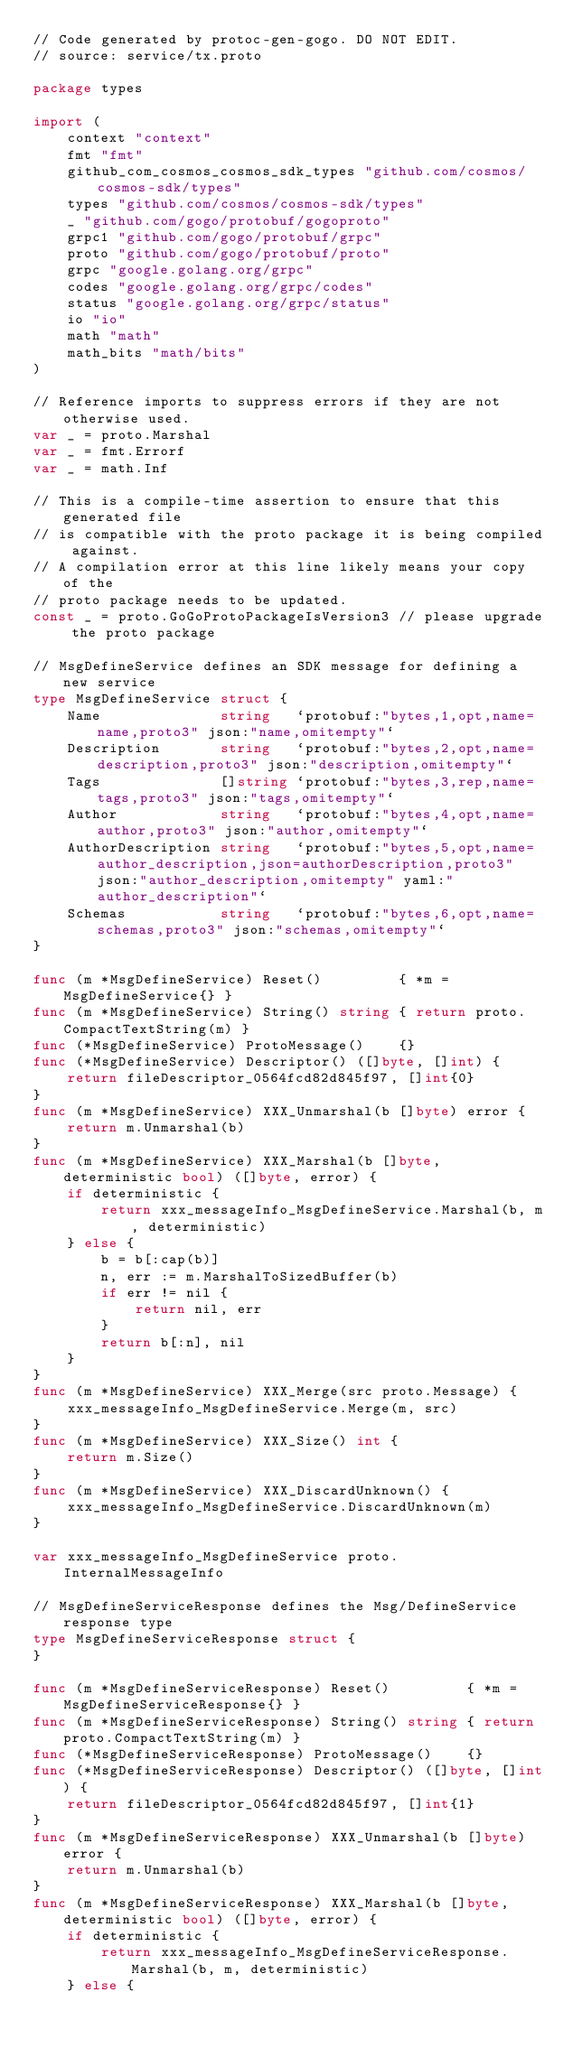<code> <loc_0><loc_0><loc_500><loc_500><_Go_>// Code generated by protoc-gen-gogo. DO NOT EDIT.
// source: service/tx.proto

package types

import (
	context "context"
	fmt "fmt"
	github_com_cosmos_cosmos_sdk_types "github.com/cosmos/cosmos-sdk/types"
	types "github.com/cosmos/cosmos-sdk/types"
	_ "github.com/gogo/protobuf/gogoproto"
	grpc1 "github.com/gogo/protobuf/grpc"
	proto "github.com/gogo/protobuf/proto"
	grpc "google.golang.org/grpc"
	codes "google.golang.org/grpc/codes"
	status "google.golang.org/grpc/status"
	io "io"
	math "math"
	math_bits "math/bits"
)

// Reference imports to suppress errors if they are not otherwise used.
var _ = proto.Marshal
var _ = fmt.Errorf
var _ = math.Inf

// This is a compile-time assertion to ensure that this generated file
// is compatible with the proto package it is being compiled against.
// A compilation error at this line likely means your copy of the
// proto package needs to be updated.
const _ = proto.GoGoProtoPackageIsVersion3 // please upgrade the proto package

// MsgDefineService defines an SDK message for defining a new service
type MsgDefineService struct {
	Name              string   `protobuf:"bytes,1,opt,name=name,proto3" json:"name,omitempty"`
	Description       string   `protobuf:"bytes,2,opt,name=description,proto3" json:"description,omitempty"`
	Tags              []string `protobuf:"bytes,3,rep,name=tags,proto3" json:"tags,omitempty"`
	Author            string   `protobuf:"bytes,4,opt,name=author,proto3" json:"author,omitempty"`
	AuthorDescription string   `protobuf:"bytes,5,opt,name=author_description,json=authorDescription,proto3" json:"author_description,omitempty" yaml:"author_description"`
	Schemas           string   `protobuf:"bytes,6,opt,name=schemas,proto3" json:"schemas,omitempty"`
}

func (m *MsgDefineService) Reset()         { *m = MsgDefineService{} }
func (m *MsgDefineService) String() string { return proto.CompactTextString(m) }
func (*MsgDefineService) ProtoMessage()    {}
func (*MsgDefineService) Descriptor() ([]byte, []int) {
	return fileDescriptor_0564fcd82d845f97, []int{0}
}
func (m *MsgDefineService) XXX_Unmarshal(b []byte) error {
	return m.Unmarshal(b)
}
func (m *MsgDefineService) XXX_Marshal(b []byte, deterministic bool) ([]byte, error) {
	if deterministic {
		return xxx_messageInfo_MsgDefineService.Marshal(b, m, deterministic)
	} else {
		b = b[:cap(b)]
		n, err := m.MarshalToSizedBuffer(b)
		if err != nil {
			return nil, err
		}
		return b[:n], nil
	}
}
func (m *MsgDefineService) XXX_Merge(src proto.Message) {
	xxx_messageInfo_MsgDefineService.Merge(m, src)
}
func (m *MsgDefineService) XXX_Size() int {
	return m.Size()
}
func (m *MsgDefineService) XXX_DiscardUnknown() {
	xxx_messageInfo_MsgDefineService.DiscardUnknown(m)
}

var xxx_messageInfo_MsgDefineService proto.InternalMessageInfo

// MsgDefineServiceResponse defines the Msg/DefineService response type
type MsgDefineServiceResponse struct {
}

func (m *MsgDefineServiceResponse) Reset()         { *m = MsgDefineServiceResponse{} }
func (m *MsgDefineServiceResponse) String() string { return proto.CompactTextString(m) }
func (*MsgDefineServiceResponse) ProtoMessage()    {}
func (*MsgDefineServiceResponse) Descriptor() ([]byte, []int) {
	return fileDescriptor_0564fcd82d845f97, []int{1}
}
func (m *MsgDefineServiceResponse) XXX_Unmarshal(b []byte) error {
	return m.Unmarshal(b)
}
func (m *MsgDefineServiceResponse) XXX_Marshal(b []byte, deterministic bool) ([]byte, error) {
	if deterministic {
		return xxx_messageInfo_MsgDefineServiceResponse.Marshal(b, m, deterministic)
	} else {</code> 